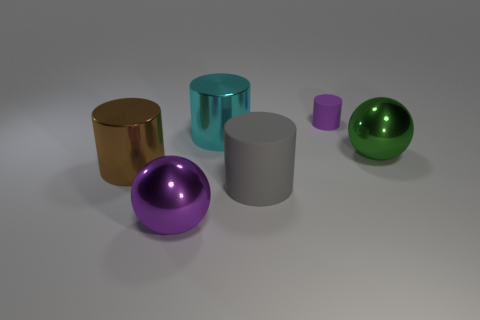Add 1 small purple matte cylinders. How many objects exist? 7 Subtract all cylinders. How many objects are left? 2 Subtract all tiny purple rubber cylinders. Subtract all matte cylinders. How many objects are left? 3 Add 3 gray matte things. How many gray matte things are left? 4 Add 3 gray matte cylinders. How many gray matte cylinders exist? 4 Subtract 1 purple cylinders. How many objects are left? 5 